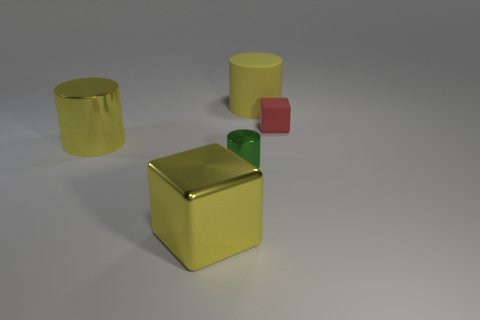Subtract all red balls. How many yellow cylinders are left? 2 Add 3 large yellow things. How many objects exist? 8 Subtract all green shiny cylinders. How many cylinders are left? 2 Subtract all cubes. How many objects are left? 3 Add 5 big matte cylinders. How many big matte cylinders are left? 6 Add 2 large purple rubber balls. How many large purple rubber balls exist? 2 Subtract 1 red blocks. How many objects are left? 4 Subtract all gray cylinders. Subtract all brown spheres. How many cylinders are left? 3 Subtract all large cubes. Subtract all big metal blocks. How many objects are left? 3 